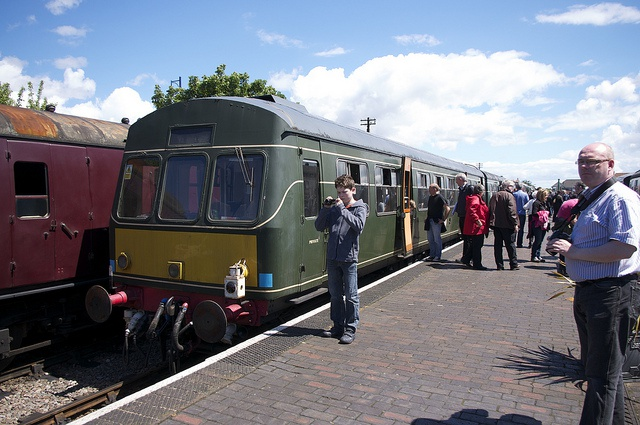Describe the objects in this image and their specific colors. I can see train in gray, black, and darkgreen tones, train in gray, black, maroon, and purple tones, people in gray, black, white, and blue tones, people in gray, black, and darkgray tones, and people in gray, black, and darkgray tones in this image. 